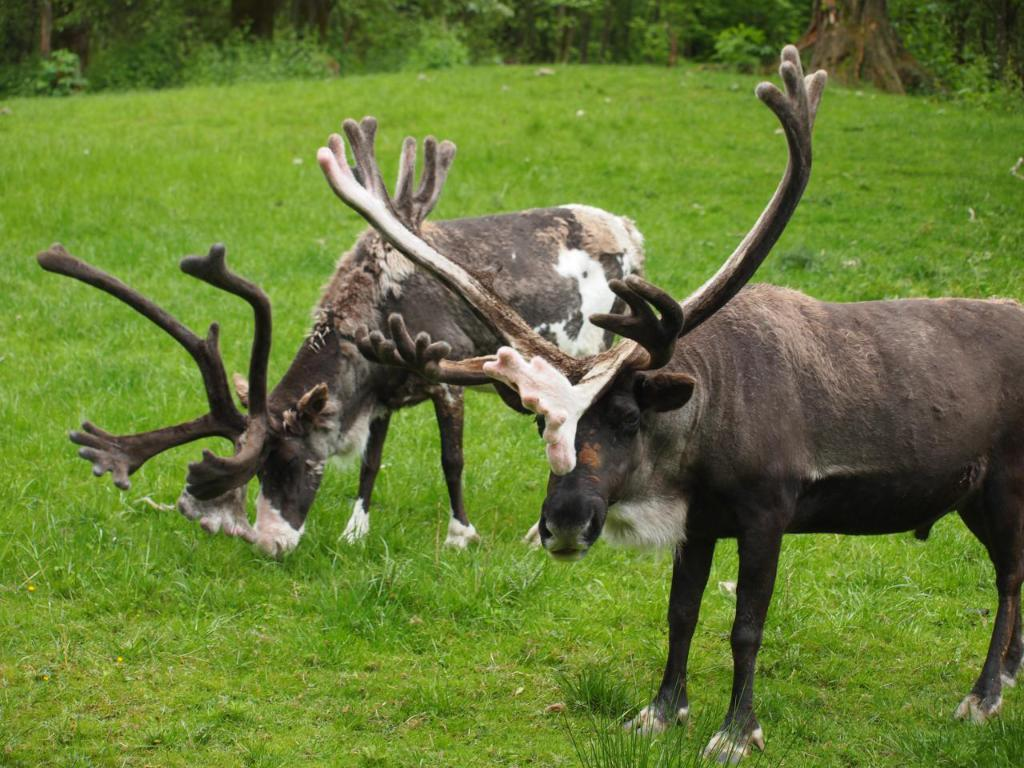How many animals are present in the image? There are two animals in the image. What colors are the animals? The animals are in brown and white colors. What are the animals doing in the image? The animals are eating. What can be seen in the background of the image? There is grass and trees in the background of the image. What color are the grass and trees? The grass and trees are green in color. Do the animals feel any shame while eating in the image? There is no indication of emotions like shame in the image, as animals do not experience emotions in the same way humans do. 